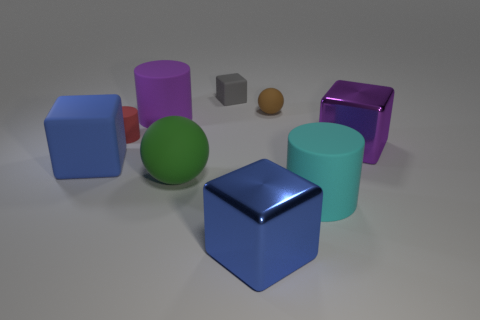Is there a pattern in how the objects are arranged? The objects do not follow a strict pattern but are casually scattered with ample space between them. The arrangement gives an appearance of random placement within an organized setting. 